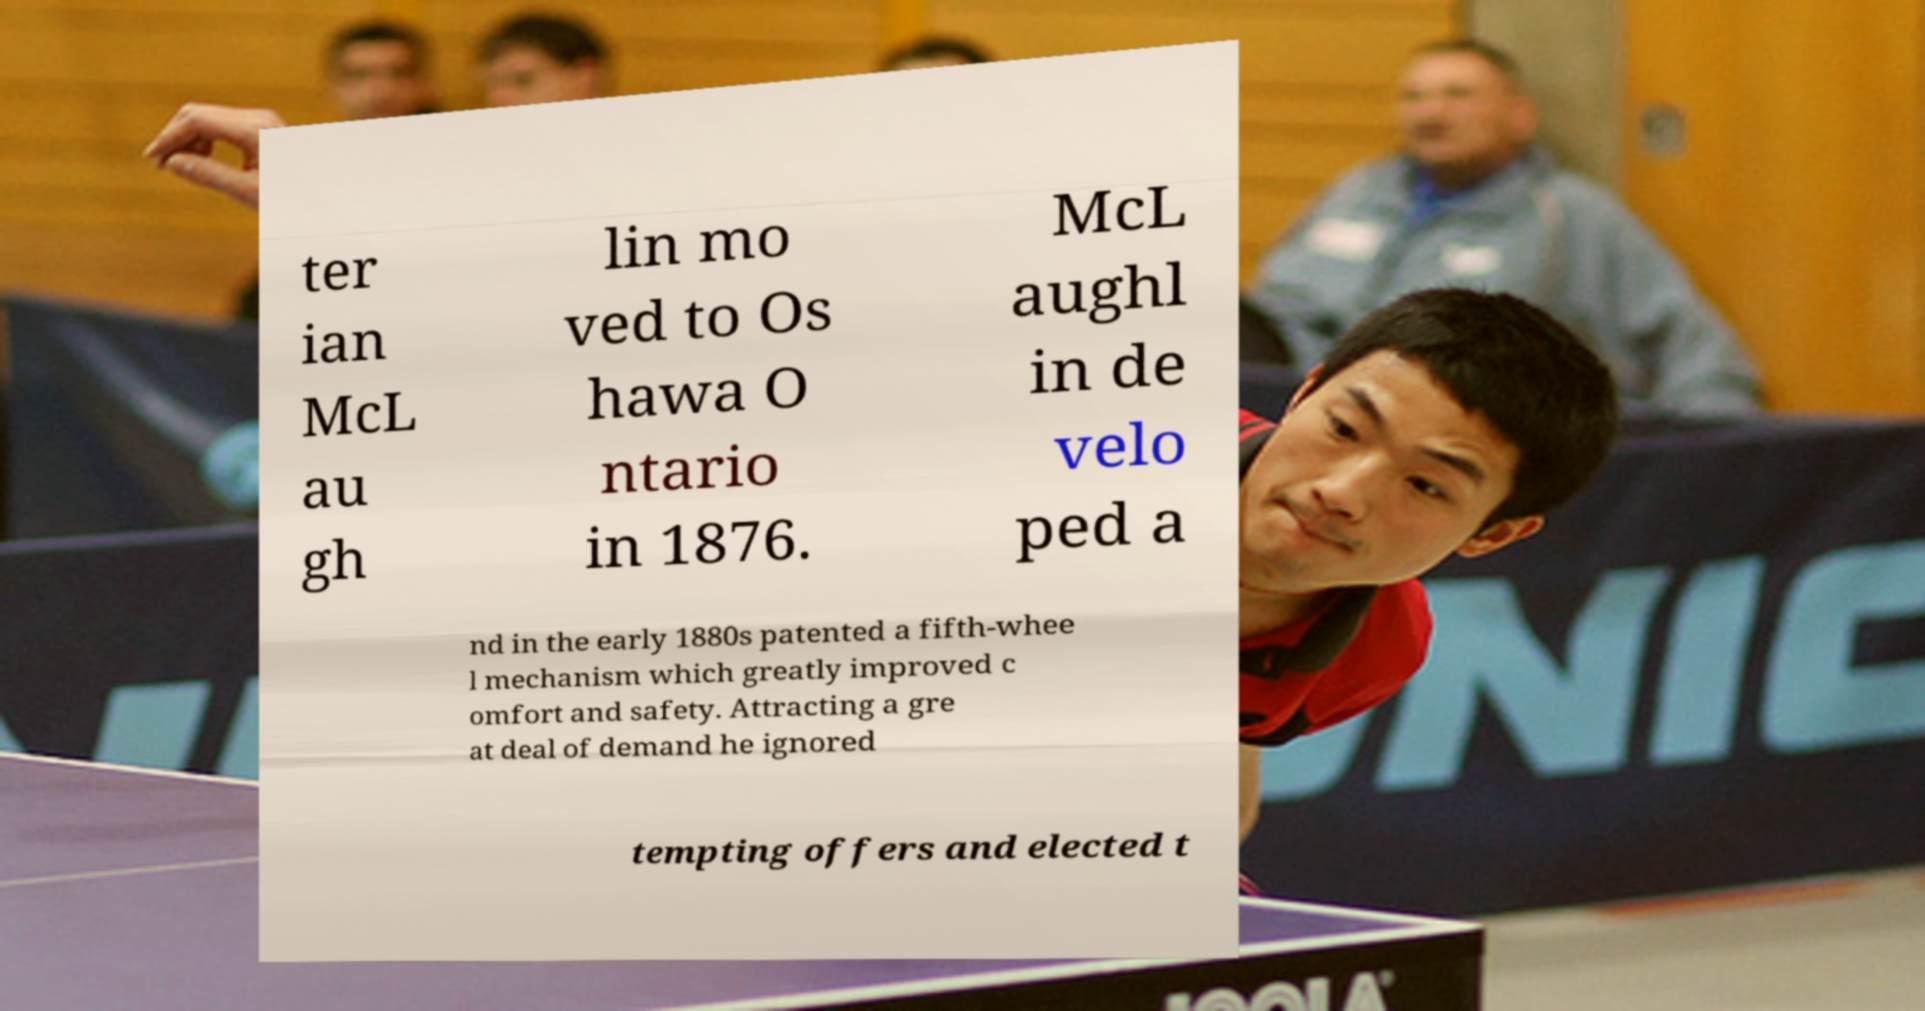I need the written content from this picture converted into text. Can you do that? ter ian McL au gh lin mo ved to Os hawa O ntario in 1876. McL aughl in de velo ped a nd in the early 1880s patented a fifth-whee l mechanism which greatly improved c omfort and safety. Attracting a gre at deal of demand he ignored tempting offers and elected t 